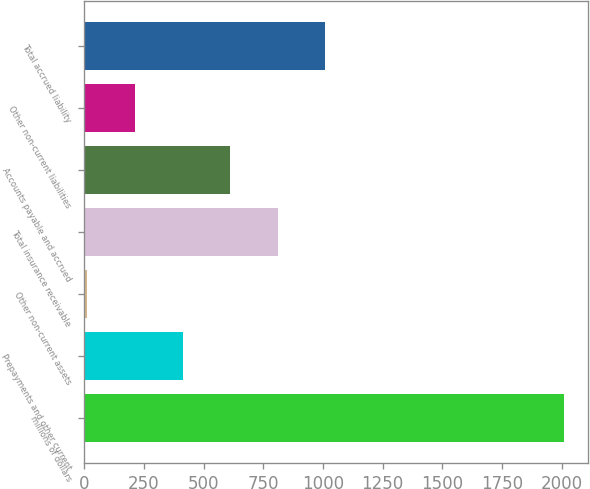Convert chart. <chart><loc_0><loc_0><loc_500><loc_500><bar_chart><fcel>millions of dollars<fcel>Prepayments and other current<fcel>Other non-current assets<fcel>Total insurance receivable<fcel>Accounts payable and accrued<fcel>Other non-current liabilities<fcel>Total accrued liability<nl><fcel>2008<fcel>411.68<fcel>12.6<fcel>810.76<fcel>611.22<fcel>212.14<fcel>1010.3<nl></chart> 